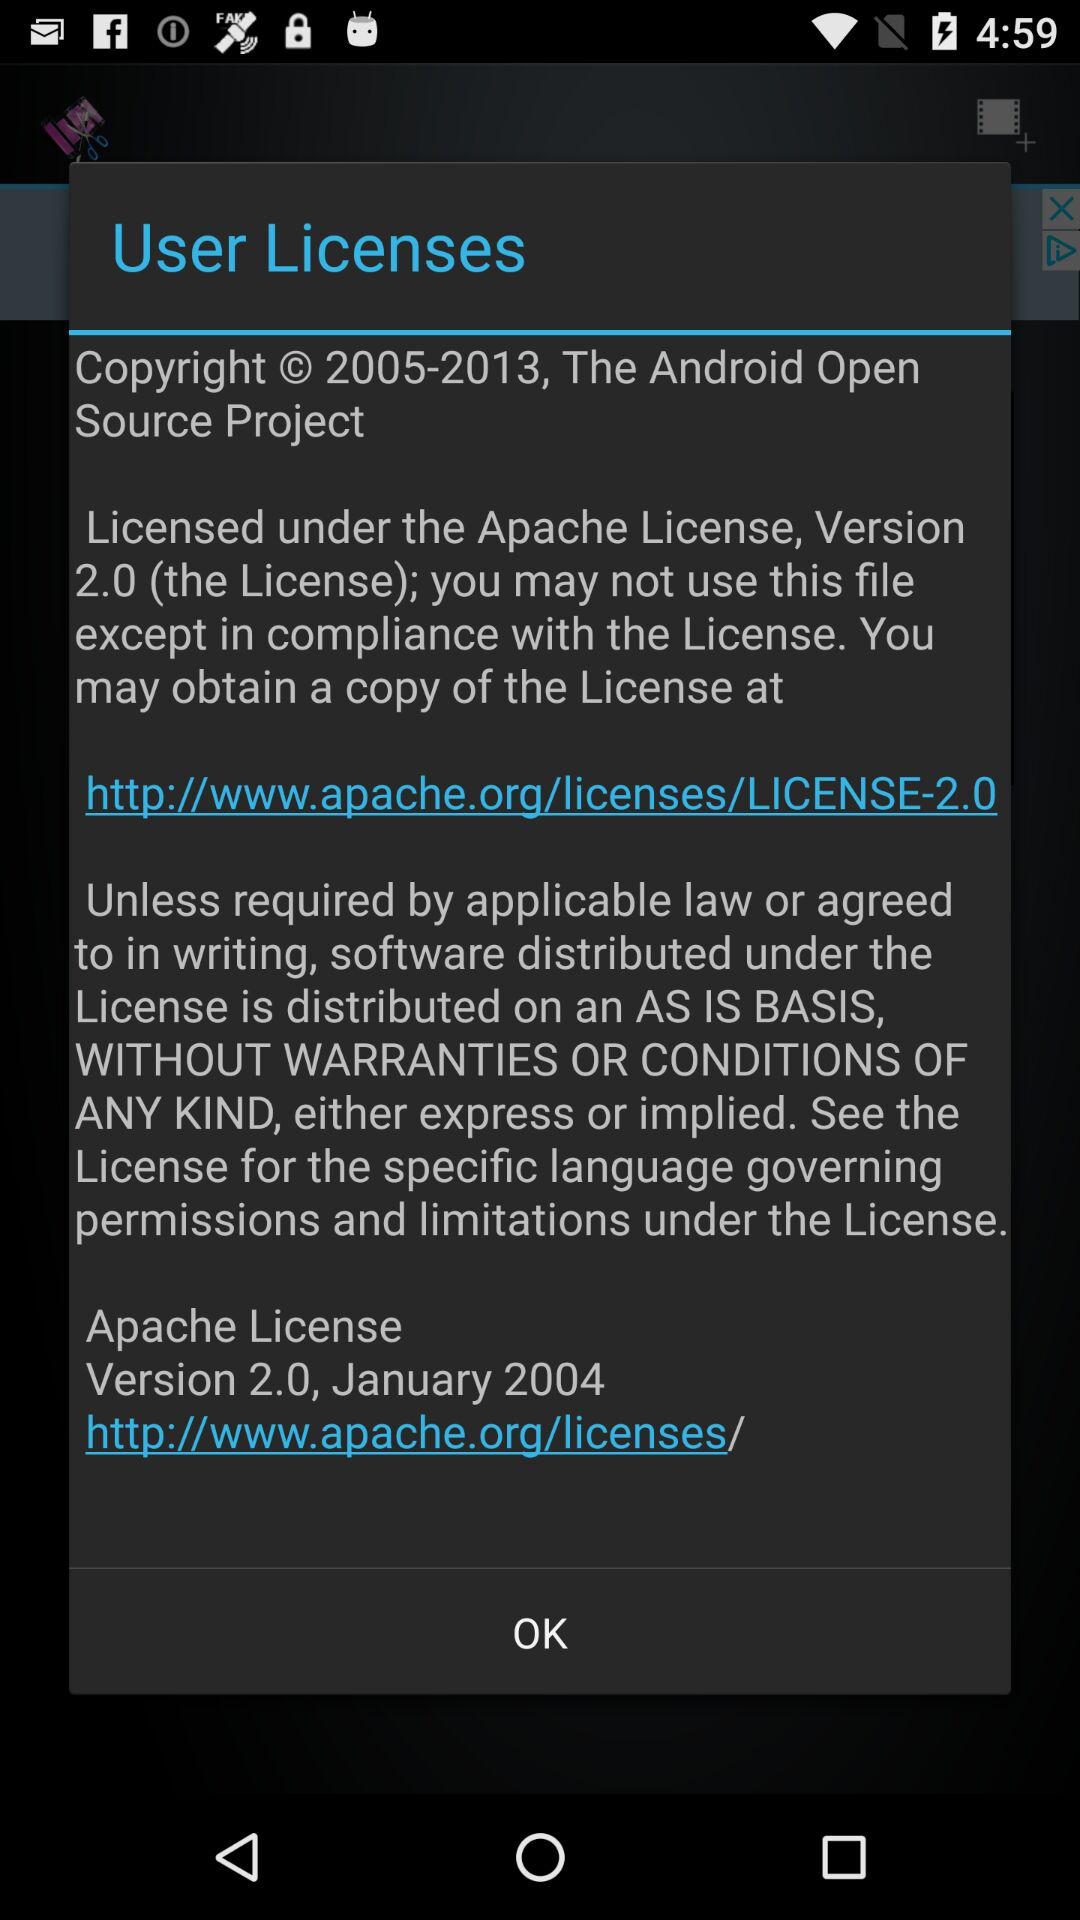What is the mail address where license copy can be obtained?
When the provided information is insufficient, respond with <no answer>. <no answer> 